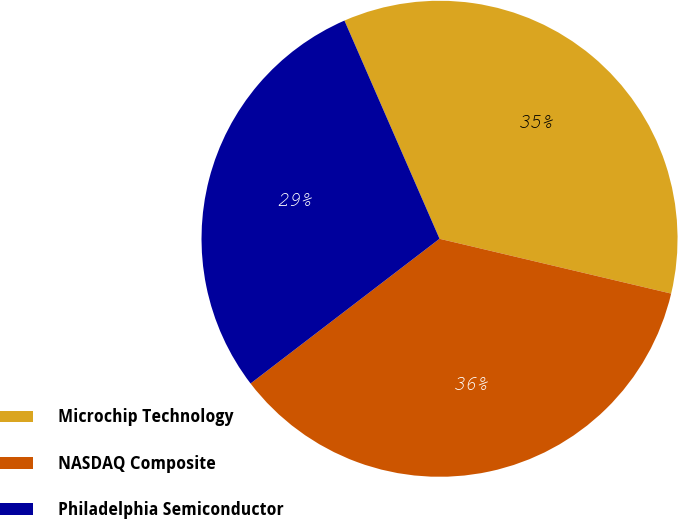<chart> <loc_0><loc_0><loc_500><loc_500><pie_chart><fcel>Microchip Technology<fcel>NASDAQ Composite<fcel>Philadelphia Semiconductor<nl><fcel>35.24%<fcel>35.9%<fcel>28.86%<nl></chart> 